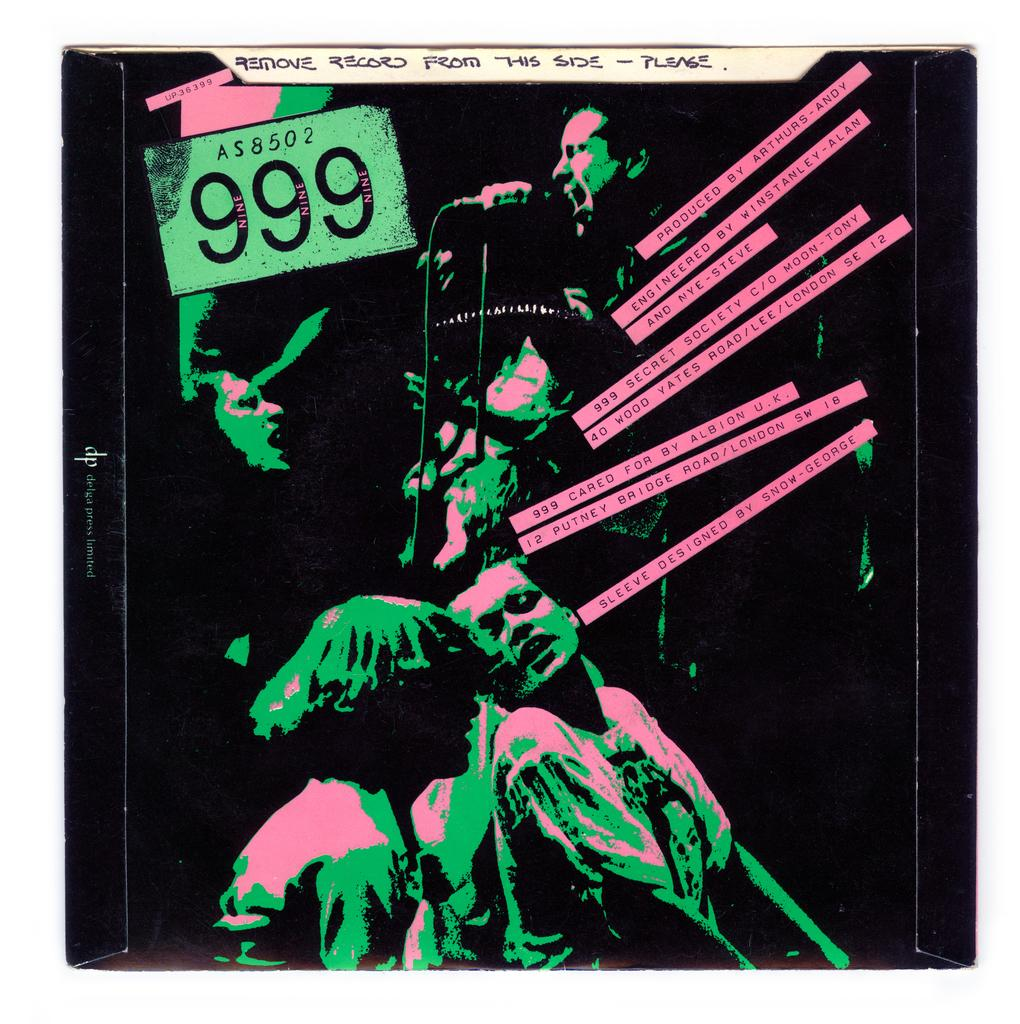<image>
Relay a brief, clear account of the picture shown. a green and pink image of someone singing with remove record from this side please written at the top 